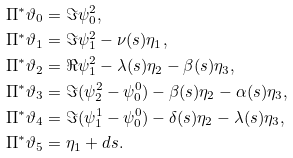Convert formula to latex. <formula><loc_0><loc_0><loc_500><loc_500>\Pi ^ { * } \vartheta _ { 0 } & = \Im \psi ^ { 2 } _ { 0 } , \\ \Pi ^ { * } \vartheta _ { 1 } & = \Im \psi ^ { 2 } _ { 1 } - \nu ( s ) \eta _ { 1 } , \\ \Pi ^ { * } \vartheta _ { 2 } & = \Re \psi ^ { 2 } _ { 1 } - \lambda ( s ) \eta _ { 2 } - \beta ( s ) \eta _ { 3 } , \\ \Pi ^ { * } \vartheta _ { 3 } & = \Im ( \psi ^ { 2 } _ { 2 } - \psi ^ { 0 } _ { 0 } ) - \beta ( s ) \eta _ { 2 } - \alpha ( s ) \eta _ { 3 } , \\ \Pi ^ { * } \vartheta _ { 4 } & = \Im ( \psi ^ { 1 } _ { 1 } - \psi ^ { 0 } _ { 0 } ) - \delta ( s ) \eta _ { 2 } - \lambda ( s ) \eta _ { 3 } , \\ \Pi ^ { * } \vartheta _ { 5 } & = \eta _ { 1 } + d s .</formula> 